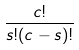Convert formula to latex. <formula><loc_0><loc_0><loc_500><loc_500>\frac { c ! } { s ! ( c - s ) ! }</formula> 